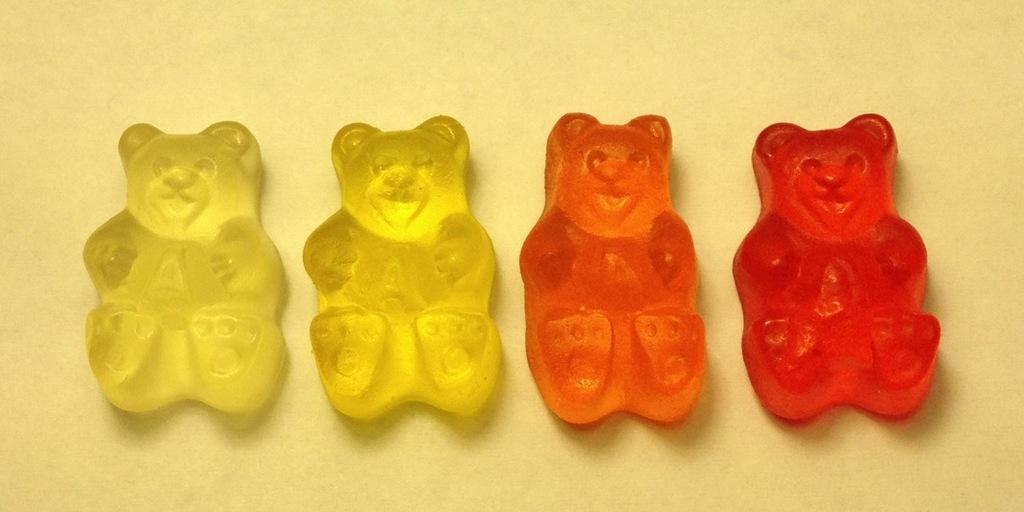How would you summarize this image in a sentence or two? In this picture I can see those are looking like the candies in the shape of a teddy bear. 